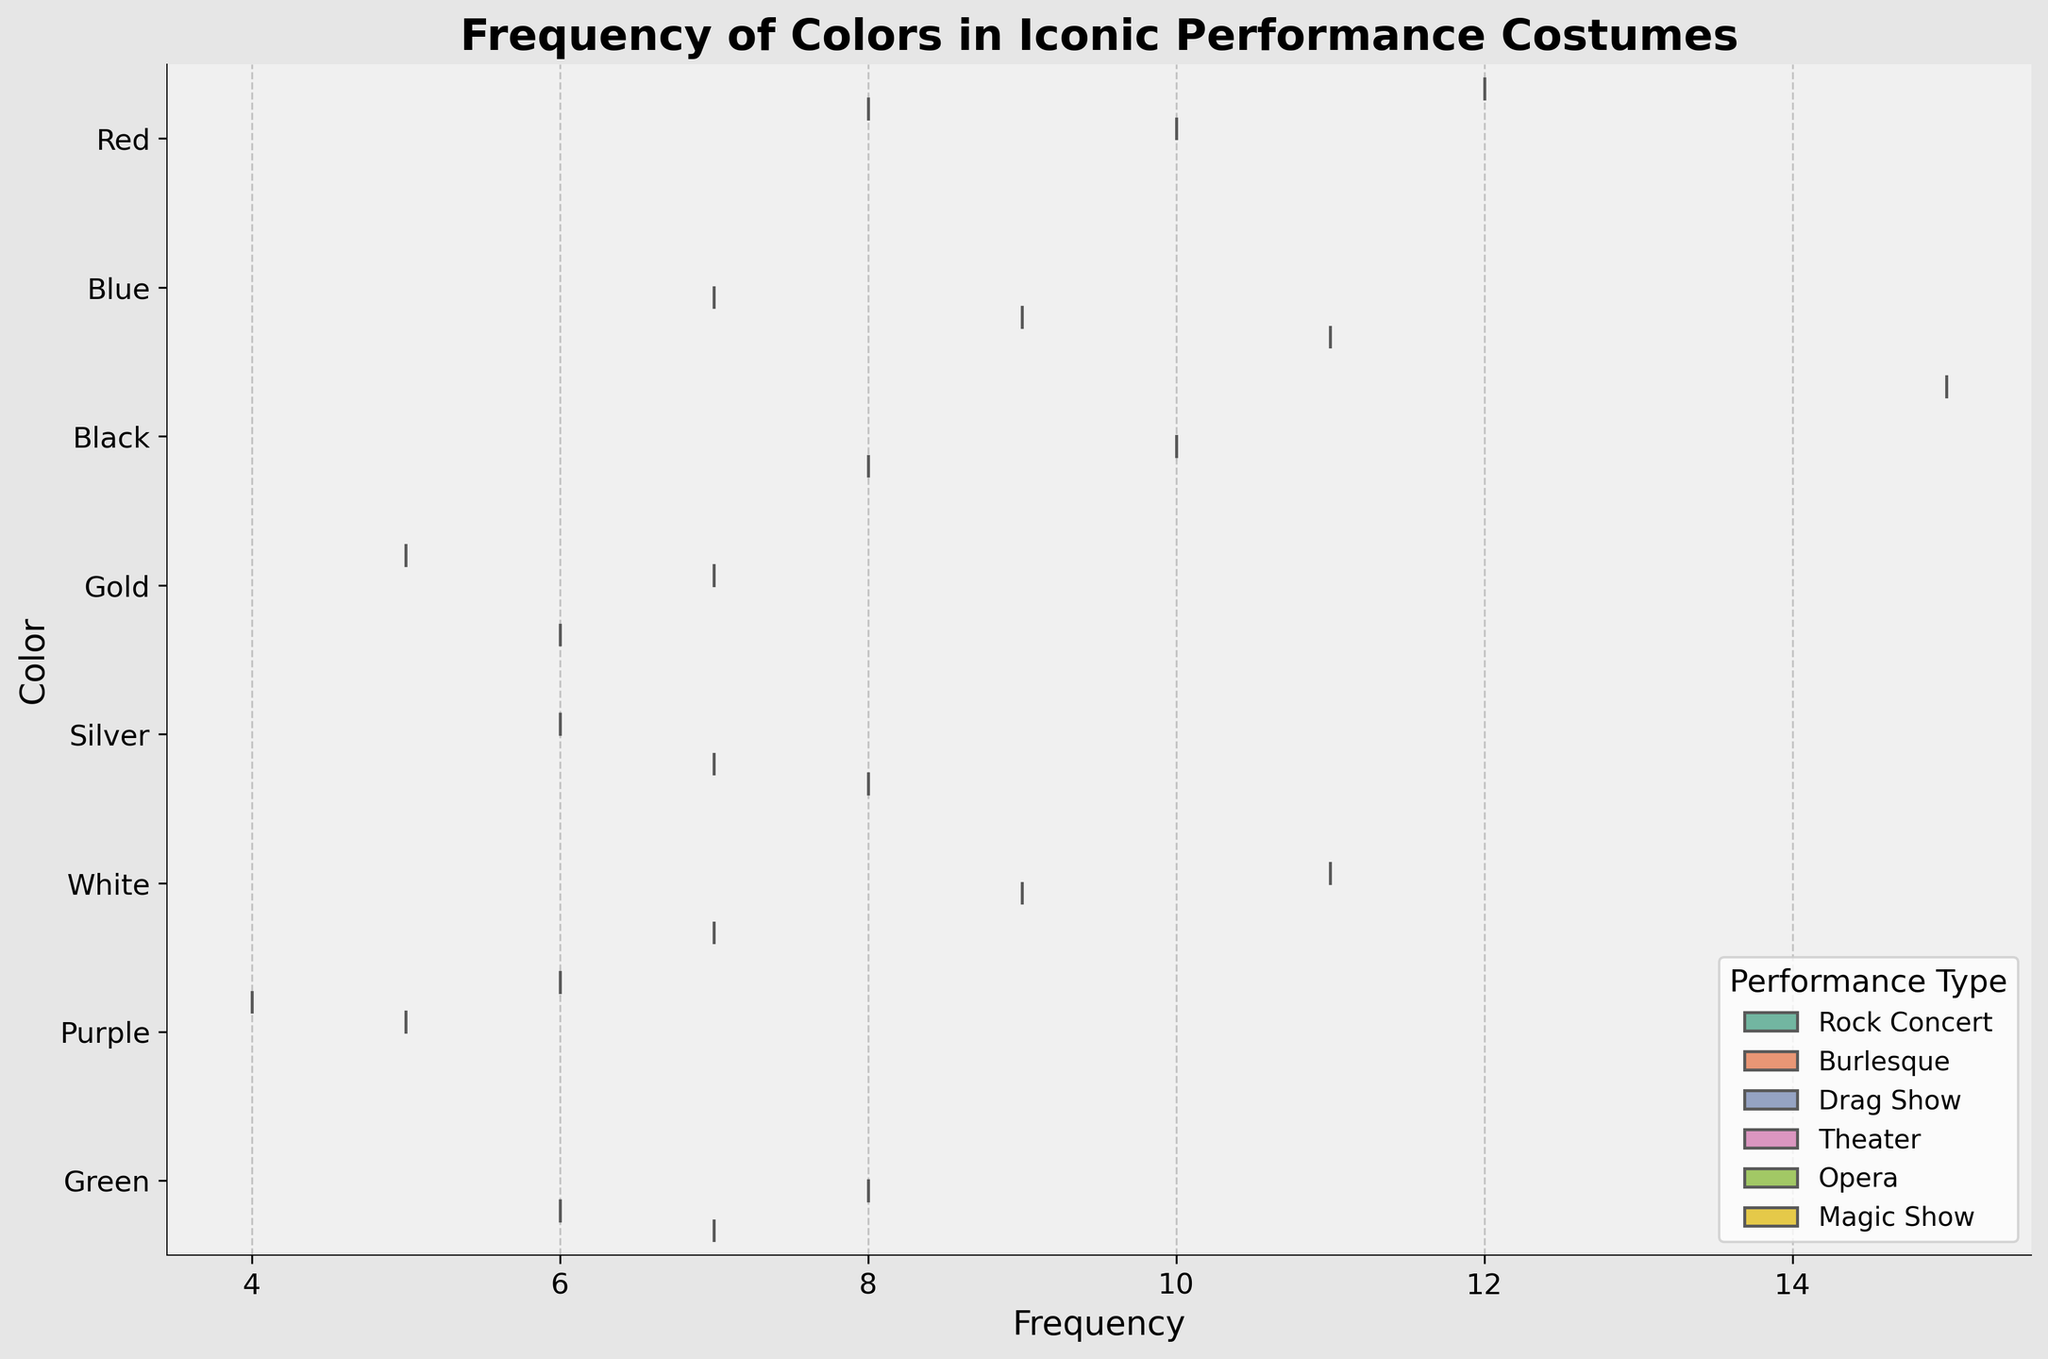What's the title of the figure? The title is generally found at the top of the figure and provides a brief description of what the figure represents.
Answer: Frequency of Colors in Iconic Performance Costumes Which color has the highest frequency in Rock Concerts? Look at the violin plots for the Rock Concerts and identify the color with the highest density peak. Black has the highest frequency in Rock Concerts.
Answer: Black What is the color with the lowest frequency in Burlesque performances? Find the color category associated with Burlesque. Purple has the lowest frequency as it has the smallest peak among all Burlesque colors.
Answer: Purple How many performance types use the color Blue? Check the different violin splits represented by performance types for the color Blue. The count reveals three performance types for Blue: Theater, Opera, and Magic Show.
Answer: 3 What's the frequency range for the color Red in Drag Shows? Identify the horizontal span of the Red violin plot under Drag Shows. The frequency range spans from 9 to 11.
Answer: 9 to 11 Which color has the broadest frequency range across all performance types? Observe the width of the horizontal span of the violin plots for each color. The Red violin plot has the broadest frequency range from 7 to 12.
Answer: Red Between Black and White costumes in Theater, which one is more frequent and by how much? Compare the peaks in the Theater section for both Black and White. Black has a frequency of 10, and White has a frequency of 9. The difference is 1.
Answer: Black by 1 What is the average frequency of the color Silver across all performance types? Calculate the average by summing the frequencies for Silver (Opera: 7, Drag Show: 6, Magic Show: 8) and dividing by the number of performance types (3). The sum is 21, and the average is 21/3 = 7.
Answer: 7 How does the frequency of Purple in Drag Shows compare to its frequency in Rock Concerts? Compare the peaks for Purple in Drag Shows (5) and Rock Concerts (6). Purple is less frequent in Drag Shows.
Answer: Drag Shows is less by 1 Which performance type has the most diverse color usage based on the violin plot? Look at the number of distinct violin splits for each performance type. Magic Show has five different colors, showing the most diversity.
Answer: Magic Show 